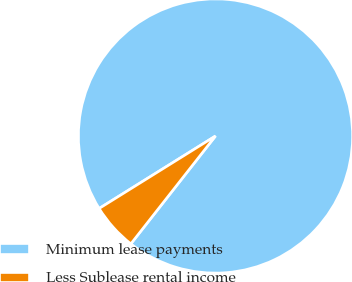Convert chart. <chart><loc_0><loc_0><loc_500><loc_500><pie_chart><fcel>Minimum lease payments<fcel>Less Sublease rental income<nl><fcel>94.46%<fcel>5.54%<nl></chart> 